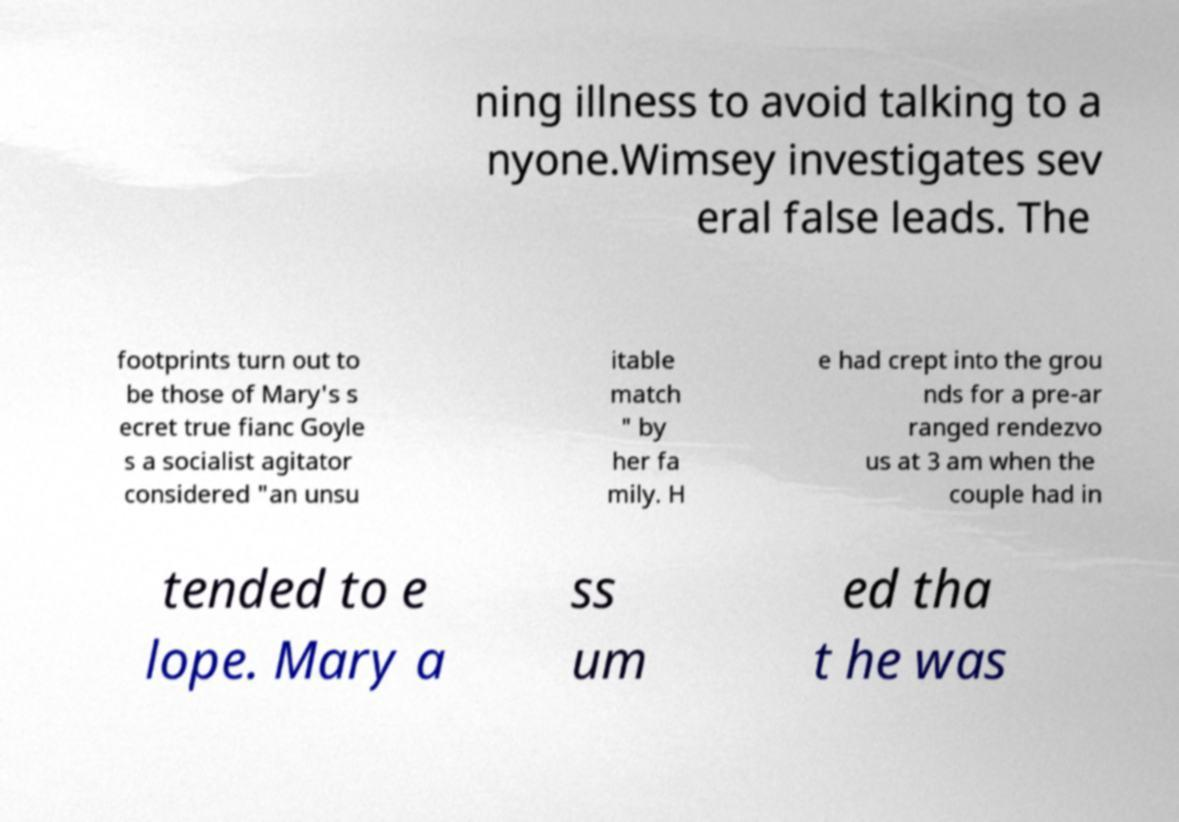Could you assist in decoding the text presented in this image and type it out clearly? ning illness to avoid talking to a nyone.Wimsey investigates sev eral false leads. The footprints turn out to be those of Mary's s ecret true fianc Goyle s a socialist agitator considered "an unsu itable match " by her fa mily. H e had crept into the grou nds for a pre-ar ranged rendezvo us at 3 am when the couple had in tended to e lope. Mary a ss um ed tha t he was 